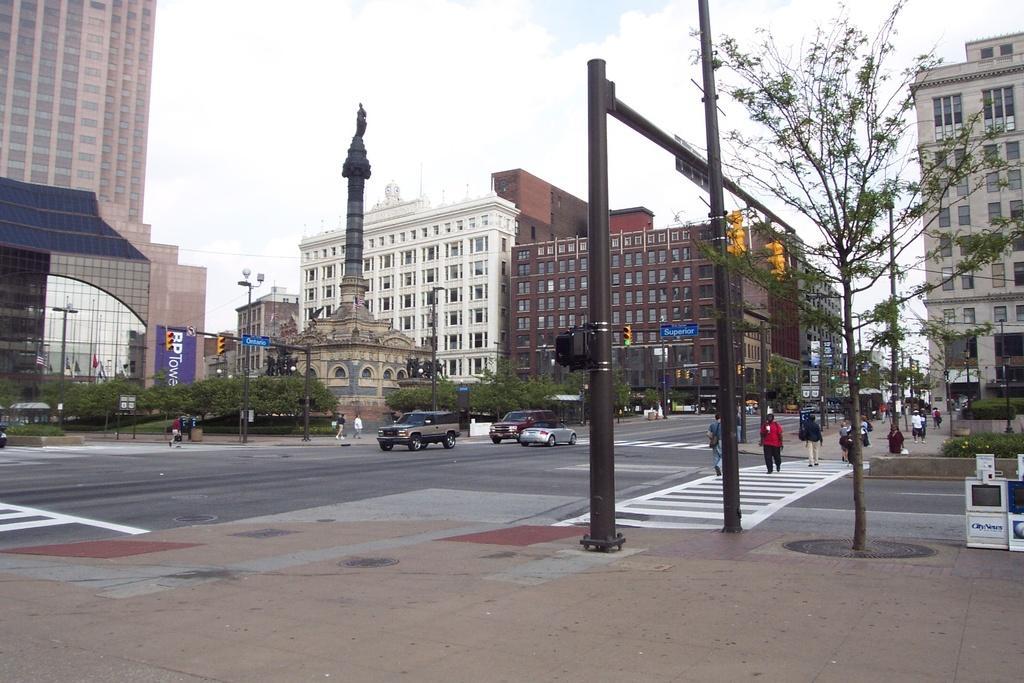In one or two sentences, can you explain what this image depicts? This image is clicked on the road. At the bottom there is a walkway. There are poles and trees on the walkway. Beside the walkway there is the road. There are vehicles moving on the road. There are people walking on the zebra crossing. On the other side of the road there are buildings, sculptures, trees, poles and boards. At the top there is the sky. 